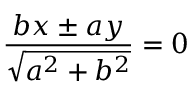Convert formula to latex. <formula><loc_0><loc_0><loc_500><loc_500>{ \frac { b x \pm a y } { \sqrt { a ^ { 2 } + b ^ { 2 } } } } = 0</formula> 